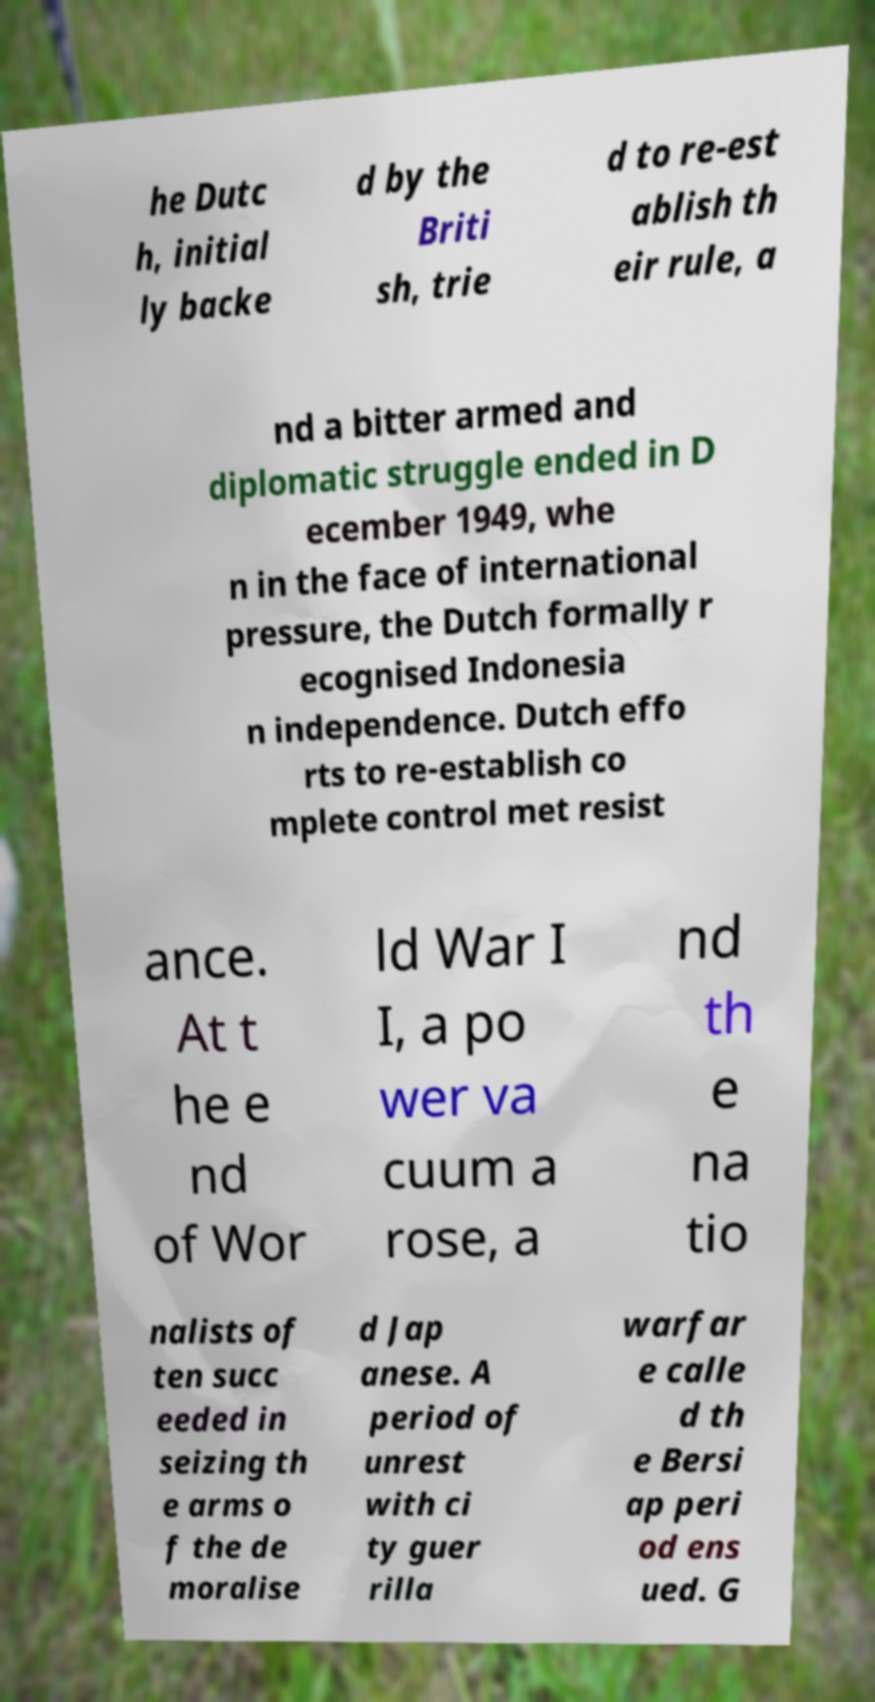What messages or text are displayed in this image? I need them in a readable, typed format. he Dutc h, initial ly backe d by the Briti sh, trie d to re-est ablish th eir rule, a nd a bitter armed and diplomatic struggle ended in D ecember 1949, whe n in the face of international pressure, the Dutch formally r ecognised Indonesia n independence. Dutch effo rts to re-establish co mplete control met resist ance. At t he e nd of Wor ld War I I, a po wer va cuum a rose, a nd th e na tio nalists of ten succ eeded in seizing th e arms o f the de moralise d Jap anese. A period of unrest with ci ty guer rilla warfar e calle d th e Bersi ap peri od ens ued. G 